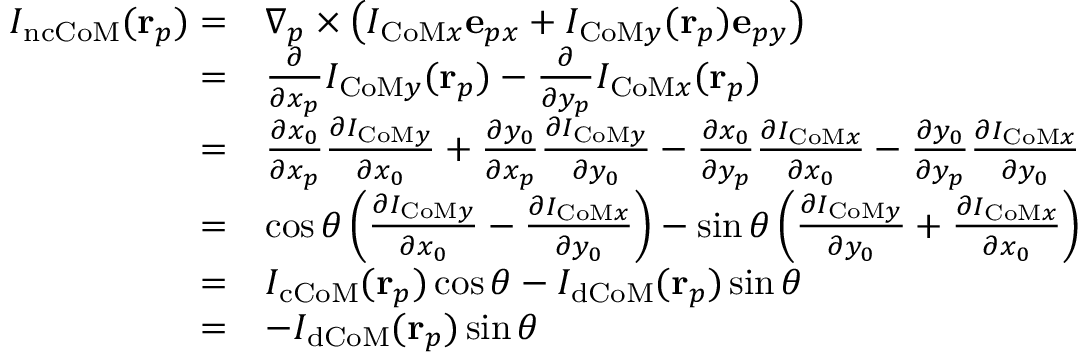<formula> <loc_0><loc_0><loc_500><loc_500>\begin{array} { r l } { I _ { n c C o M } ( r _ { p } ) = } & { \nabla _ { p } \times \left ( I _ { C o M x } e _ { p x } + I _ { C o M y } ( r _ { p } ) e _ { p y } \right ) } \\ { = } & { \frac { \partial } { \partial x _ { p } } I _ { C o M y } ( r _ { p } ) - \frac { \partial } { \partial y _ { p } } I _ { C o M x } ( r _ { p } ) } \\ { = } & { \frac { \partial x _ { 0 } } { \partial x _ { p } } \frac { \partial I _ { C o M y } } { \partial x _ { 0 } } + \frac { \partial y _ { 0 } } { \partial x _ { p } } \frac { \partial I _ { C o M y } } { \partial y _ { 0 } } - \frac { \partial x _ { 0 } } { \partial y _ { p } } \frac { \partial I _ { C o M x } } { \partial x _ { 0 } } - \frac { \partial y _ { 0 } } { \partial y _ { p } } \frac { \partial I _ { C o M x } } { \partial y _ { 0 } } } \\ { = } & { \cos \theta \left ( \frac { \partial I _ { C o M y } } { \partial x _ { 0 } } - \frac { \partial I _ { C o M x } } { \partial y _ { 0 } } \right ) - \sin \theta \left ( \frac { \partial I _ { C o M y } } { \partial y _ { 0 } } + \frac { \partial I _ { C o M x } } { \partial x _ { 0 } } \right ) } \\ { = } & { I _ { c C o M } ( r _ { p } ) \cos \theta - I _ { d C o M } ( r _ { p } ) \sin \theta } \\ { = } & { - I _ { d C o M } ( r _ { p } ) \sin \theta } \end{array}</formula> 